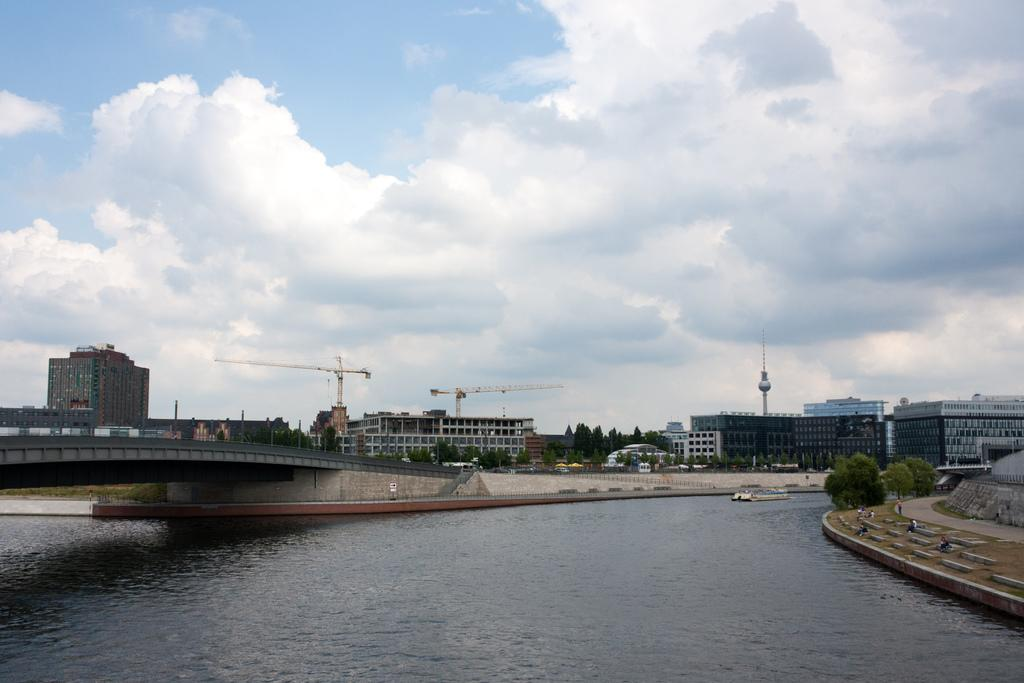What can you describe the foreground of the picture? In the foreground of the picture, there is a canal, a bridge, grass, stones, and trees. What can be seen in the center of the picture? In the center of the picture, there are buildings, cranes, and trees. How would you describe the sky in the picture? The sky in the picture is cloudy. What is the income of the person who built the bridge in the picture? There is no information about the person who built the bridge or their income in the picture. What grade is the canal in the picture? The canal is not a student or being graded, so it does not have a grade. 